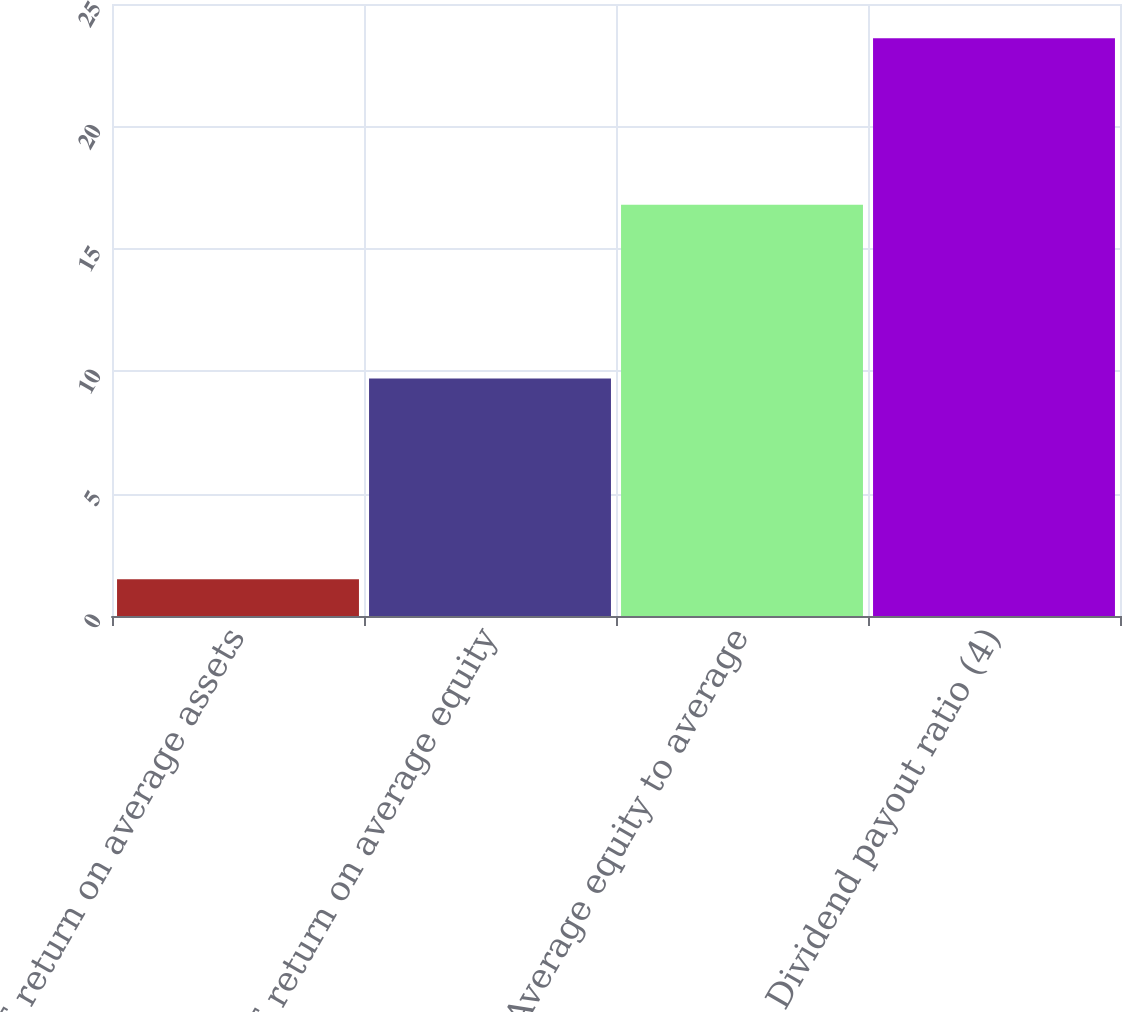Convert chart. <chart><loc_0><loc_0><loc_500><loc_500><bar_chart><fcel>RJF return on average assets<fcel>RJF return on average equity<fcel>Average equity to average<fcel>Dividend payout ratio (4)<nl><fcel>1.5<fcel>9.7<fcel>16.8<fcel>23.6<nl></chart> 